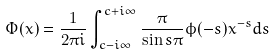Convert formula to latex. <formula><loc_0><loc_0><loc_500><loc_500>\Phi ( x ) = \frac { 1 } { 2 \pi i } \int _ { c - i \infty } ^ { c + i \infty } \frac { \pi } { \sin s \pi } \phi ( - s ) x ^ { - s } d s</formula> 